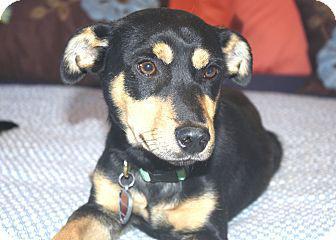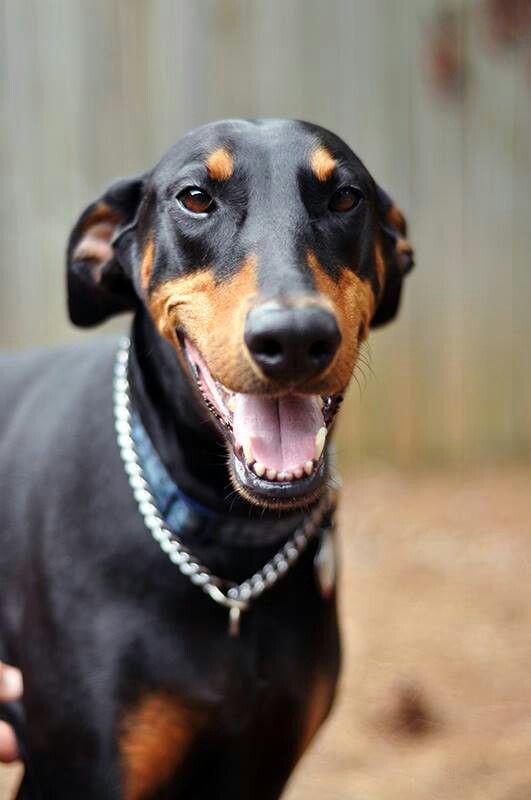The first image is the image on the left, the second image is the image on the right. Analyze the images presented: Is the assertion "In at least one image there is a black and brown puppy with a heart tag on his collar, laying down." valid? Answer yes or no. Yes. The first image is the image on the left, the second image is the image on the right. Evaluate the accuracy of this statement regarding the images: "One of the dogs is looking directly at the camera, and one of the dogs has an open mouth.". Is it true? Answer yes or no. Yes. 